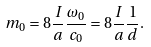Convert formula to latex. <formula><loc_0><loc_0><loc_500><loc_500>m _ { 0 } = 8 \frac { I } { a } \frac { \omega _ { 0 } } { c _ { 0 } } = 8 \frac { I } { a } \frac { 1 } { d } .</formula> 